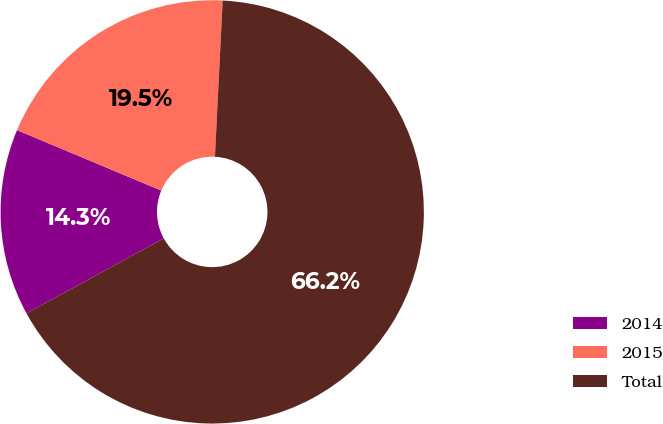Convert chart to OTSL. <chart><loc_0><loc_0><loc_500><loc_500><pie_chart><fcel>2014<fcel>2015<fcel>Total<nl><fcel>14.28%<fcel>19.47%<fcel>66.25%<nl></chart> 